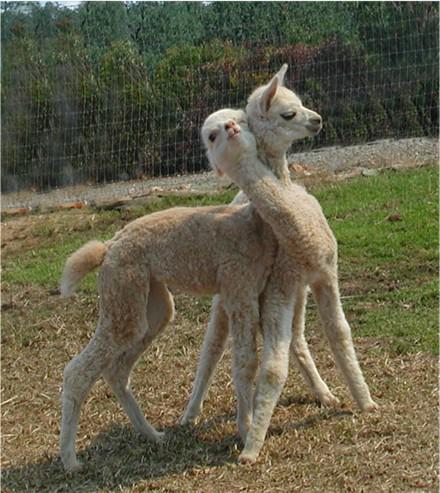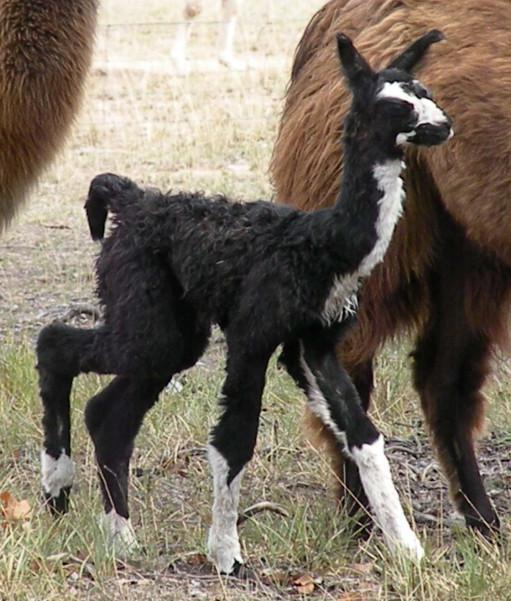The first image is the image on the left, the second image is the image on the right. Considering the images on both sides, is "In at least one image there is a brown adult lama next to its black and white baby lama." valid? Answer yes or no. Yes. The first image is the image on the left, the second image is the image on the right. For the images shown, is this caption "In one of the images, two llamas are looking at the camera." true? Answer yes or no. No. 